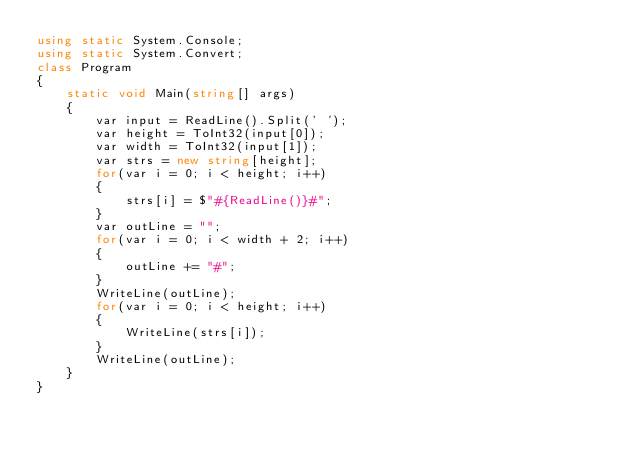<code> <loc_0><loc_0><loc_500><loc_500><_C#_>using static System.Console;
using static System.Convert;
class Program
{
    static void Main(string[] args)
    {
        var input = ReadLine().Split(' ');
        var height = ToInt32(input[0]);
        var width = ToInt32(input[1]);
        var strs = new string[height];
        for(var i = 0; i < height; i++)
        {
            strs[i] = $"#{ReadLine()}#";
        }
        var outLine = "";
        for(var i = 0; i < width + 2; i++)
        {
            outLine += "#";
        }
        WriteLine(outLine);
        for(var i = 0; i < height; i++)
        {
            WriteLine(strs[i]);
        }
        WriteLine(outLine);
    }
}

</code> 